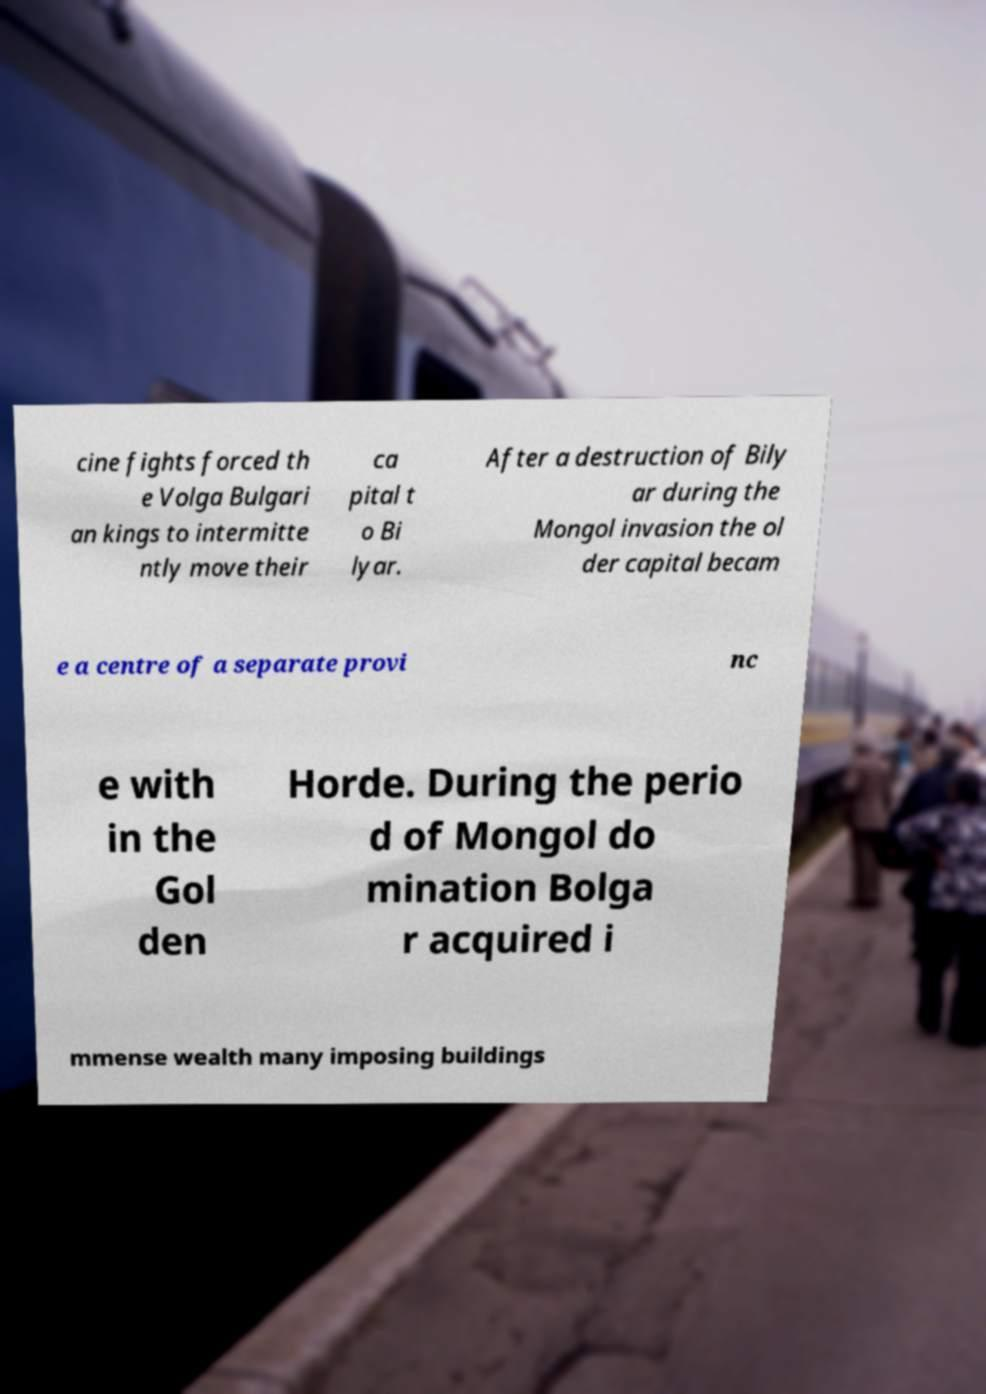For documentation purposes, I need the text within this image transcribed. Could you provide that? cine fights forced th e Volga Bulgari an kings to intermitte ntly move their ca pital t o Bi lyar. After a destruction of Bily ar during the Mongol invasion the ol der capital becam e a centre of a separate provi nc e with in the Gol den Horde. During the perio d of Mongol do mination Bolga r acquired i mmense wealth many imposing buildings 